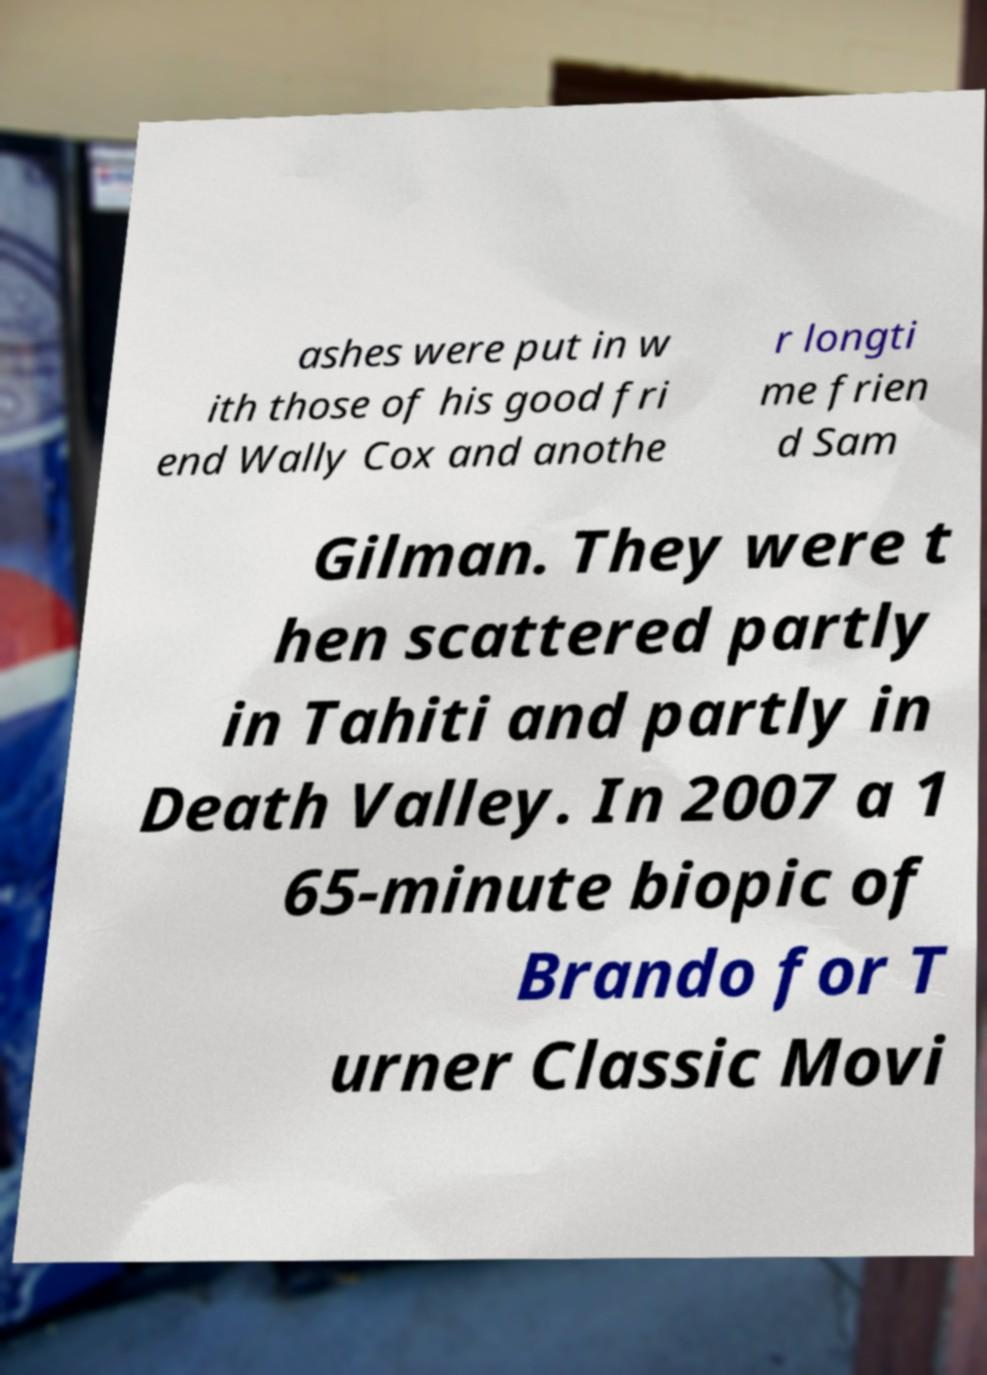Can you read and provide the text displayed in the image?This photo seems to have some interesting text. Can you extract and type it out for me? ashes were put in w ith those of his good fri end Wally Cox and anothe r longti me frien d Sam Gilman. They were t hen scattered partly in Tahiti and partly in Death Valley. In 2007 a 1 65-minute biopic of Brando for T urner Classic Movi 